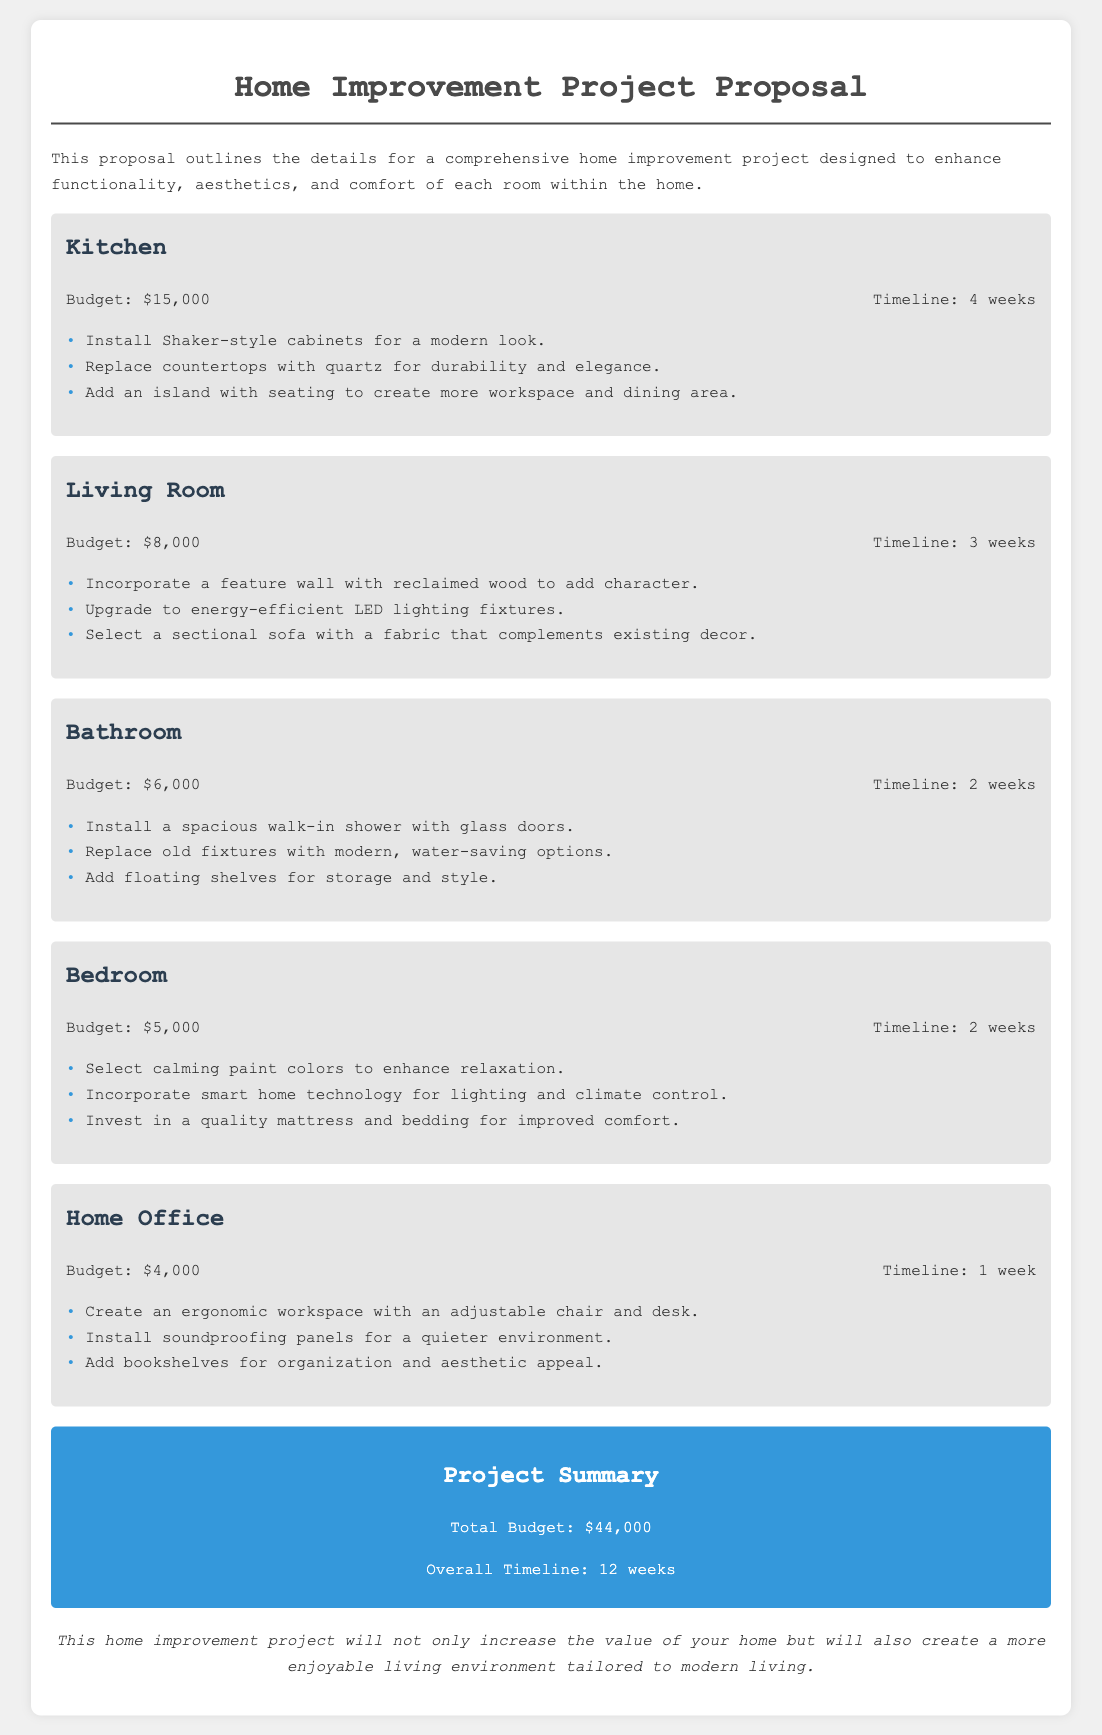what is the budget for the kitchen? The kitchen budget is clearly stated as $15,000 in the document.
Answer: $15,000 how long will the bathroom renovation take? The timeline for the bathroom renovation is stated to be 2 weeks.
Answer: 2 weeks what is one design idea proposed for the living room? One design idea for the living room is to incorporate a feature wall with reclaimed wood.
Answer: feature wall with reclaimed wood what is the total budget for the entire project? The total budget for the project is listed as $44,000.
Answer: $44,000 how does the timeline for the home office compare to the kitchen? The home office takes 1 week, while the kitchen takes 4 weeks, indicating that the home office requires less time.
Answer: less time how many rooms are included in the proposal? The document lists five rooms: Kitchen, Living Room, Bathroom, Bedroom, and Home Office.
Answer: five rooms what is one common theme found in the design ideas for the bedrooms? The design ideas for the bedroom emphasize relaxation, particularly through color selection.
Answer: relaxation what type of lighting is suggested for the living room? The proposal suggests upgrading to energy-efficient LED lighting fixtures for the living room.
Answer: energy-efficient LED lighting fixtures what will the project ultimately enhance in the home? The proposal highlights that the project will enhance functionality, aesthetics, and comfort of the home.
Answer: functionality, aesthetics, and comfort 